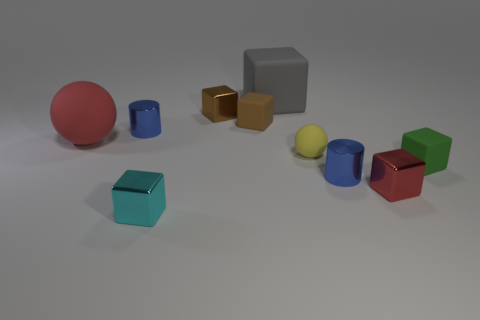Subtract all red cubes. How many cubes are left? 5 Subtract all tiny red cubes. How many cubes are left? 5 Subtract all brown blocks. Subtract all blue spheres. How many blocks are left? 4 Subtract all spheres. How many objects are left? 8 Subtract 0 blue spheres. How many objects are left? 10 Subtract all large brown shiny cylinders. Subtract all tiny red things. How many objects are left? 9 Add 8 large matte things. How many large matte things are left? 10 Add 5 brown metallic objects. How many brown metallic objects exist? 6 